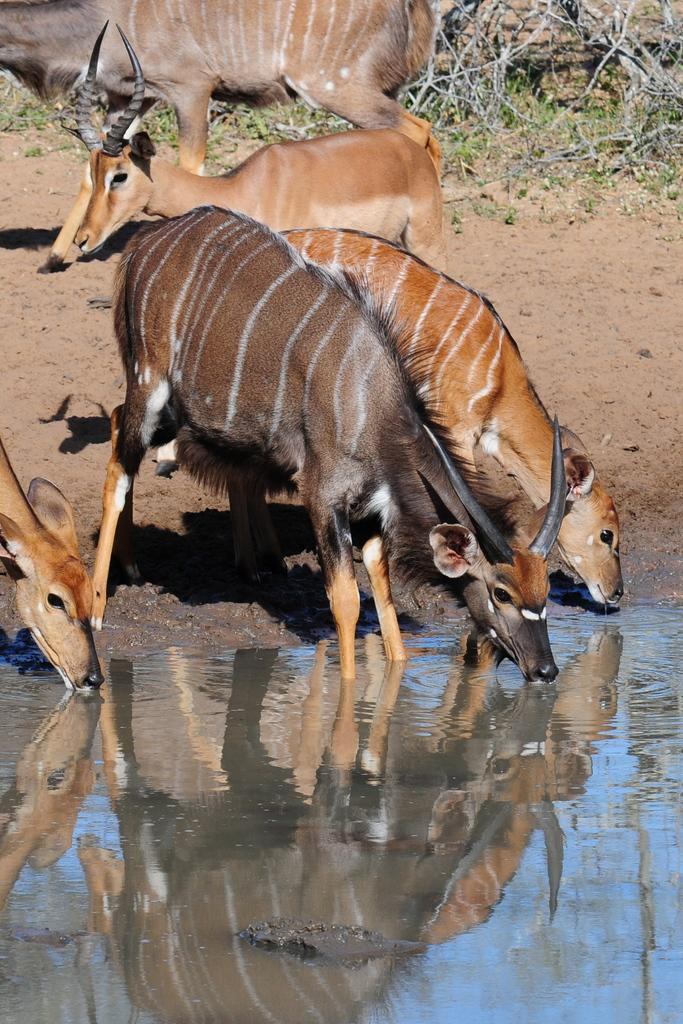What type of living organisms can be seen in the image? There are animals in the image. What colors are the animals in the image? The animals are in brown and black colors. What natural elements are visible in the image? There is water and grass visible in the image. What objects can be seen in the image? There are sticks in the image. What type of servant can be seen attending to the animals in the image? There is no servant present in the image; it only features animals, water, grass, and sticks. What type of gold object is visible in the image? There is no gold object present in the image. 